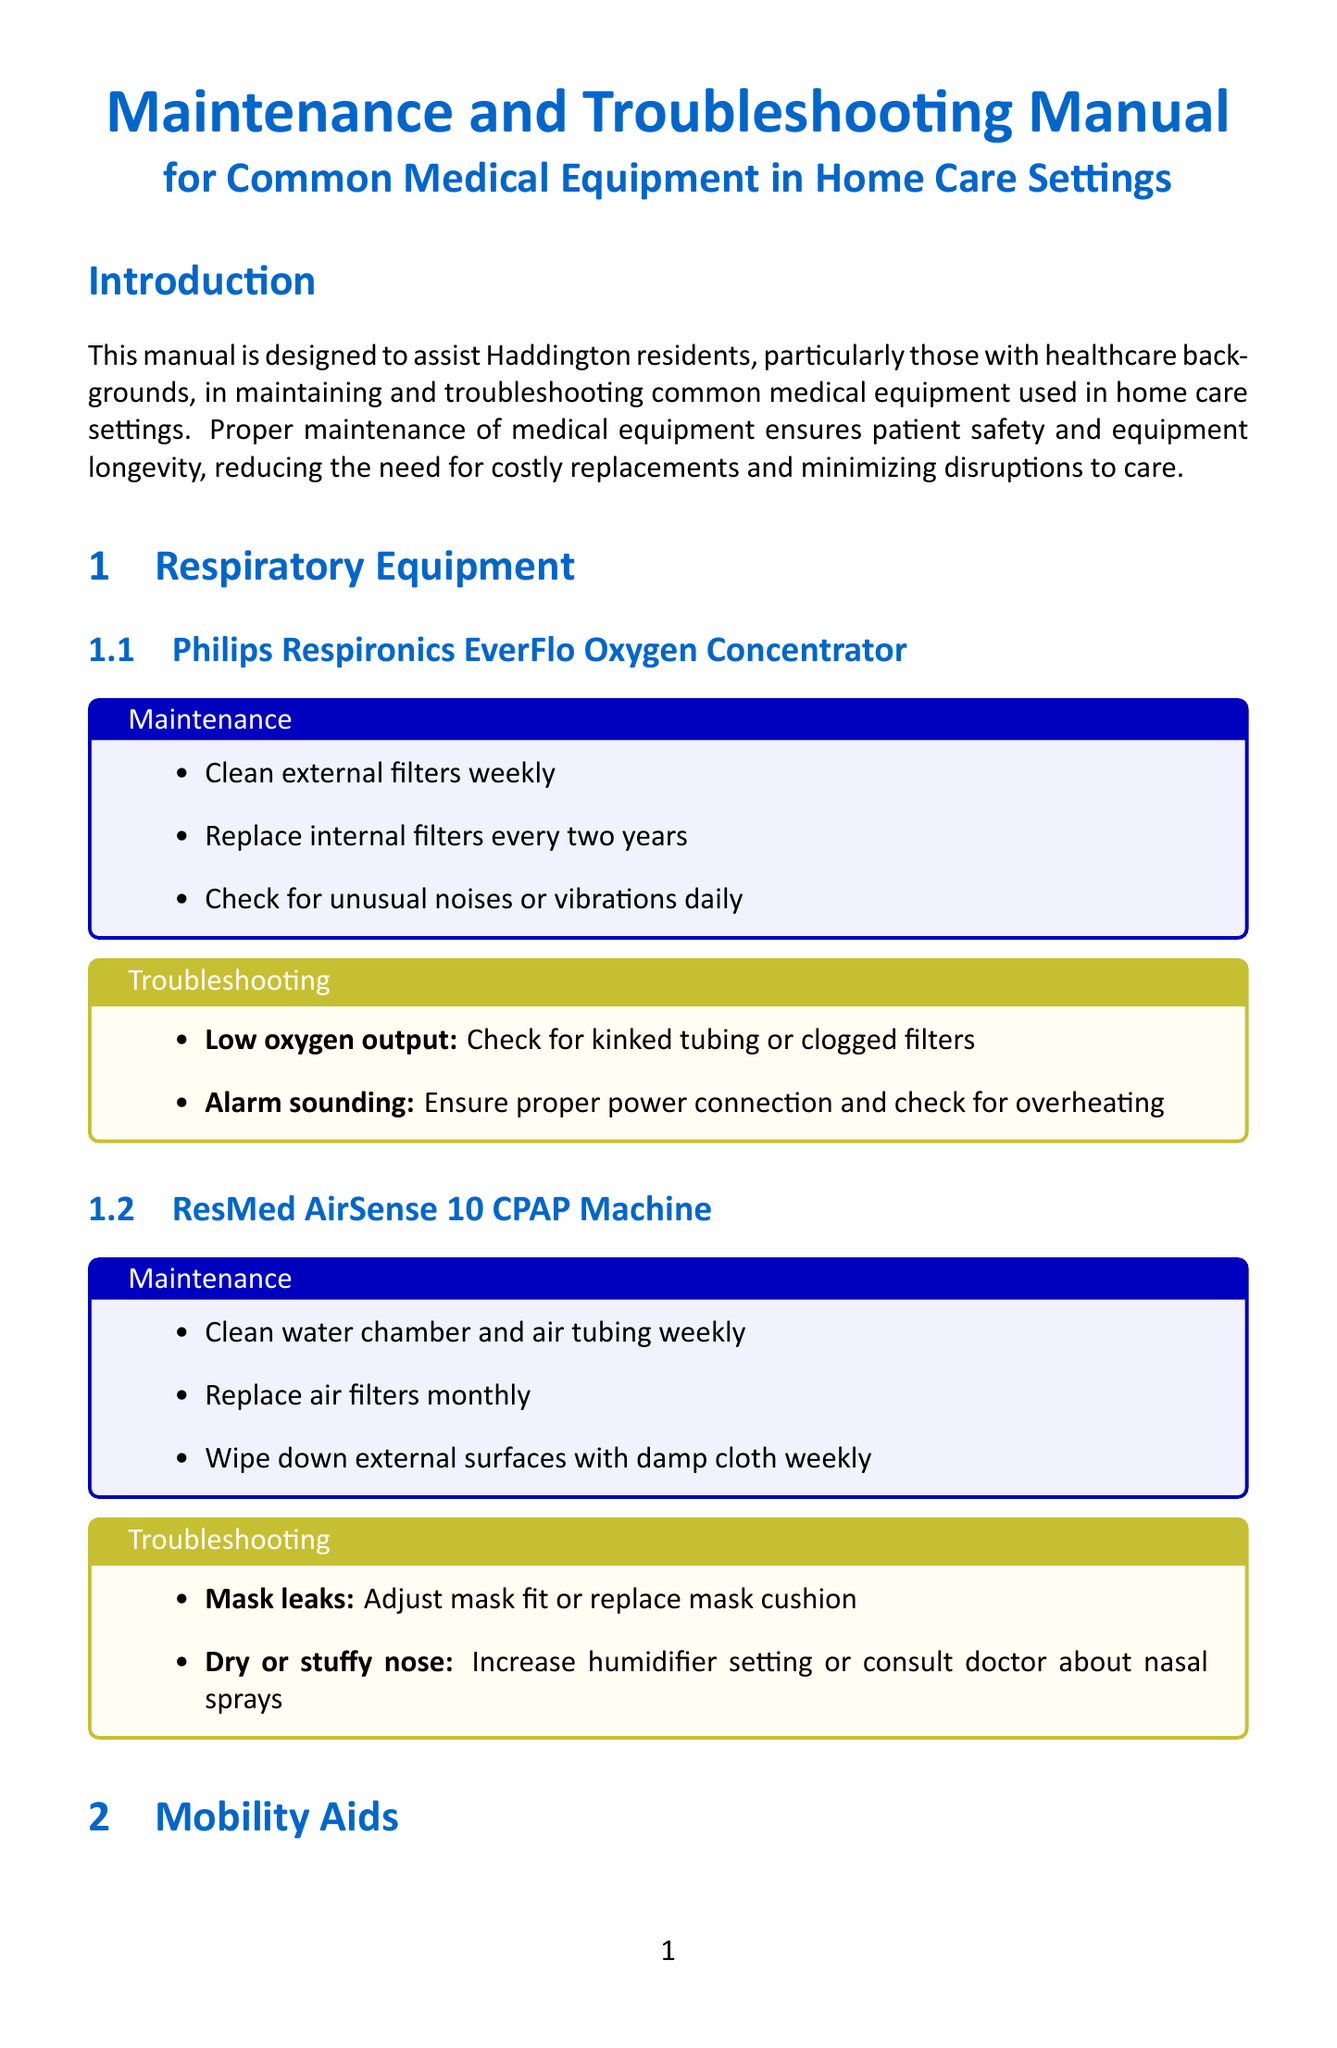what is the purpose of this manual? The purpose is to assist Haddington residents, particularly those with healthcare backgrounds, in maintaining and troubleshooting common medical equipment used in home care settings.
Answer: assist Haddington residents what is the maintenance frequency for the Philips Respironics EverFlo Oxygen Concentrator's external filters? The document states that the external filters should be cleaned weekly.
Answer: weekly which device requires its sensor to be replaced every 14 days? The Freestyle Libre 2 Continuous Glucose Monitoring System requires its sensor to be replaced every 14 days.
Answer: Freestyle Libre 2 Continuous Glucose Monitoring System what should be done if the ResMed AirSense 10 CPAP Machine has mask leaks? The solution is to adjust mask fit or replace mask cushion.
Answer: adjust mask fit or replace mask cushion where can residents find equipment suppliers in Haddington? Equipment suppliers listed in the document include Lothian Health Care and M&S Mobility.
Answer: Lothian Health Care and M&S Mobility what is a common troubleshooting step for the Omron 10 Series Blood Pressure Monitor if there are inconsistent readings? The common troubleshooting step is to ensure proper cuff placement and patient positioning.
Answer: ensure proper cuff placement what is the cleaning recommendation for the water chamber of the ResMed AirSense 10 CPAP Machine? The water chamber should be cleaned weekly.
Answer: cleaned weekly what type of support services are mentioned in the document? The document mentions local healthcare support services such as East Lothian Community Hospital and Haddington Medical Practice.
Answer: East Lothian Community Hospital and Haddington Medical Practice 